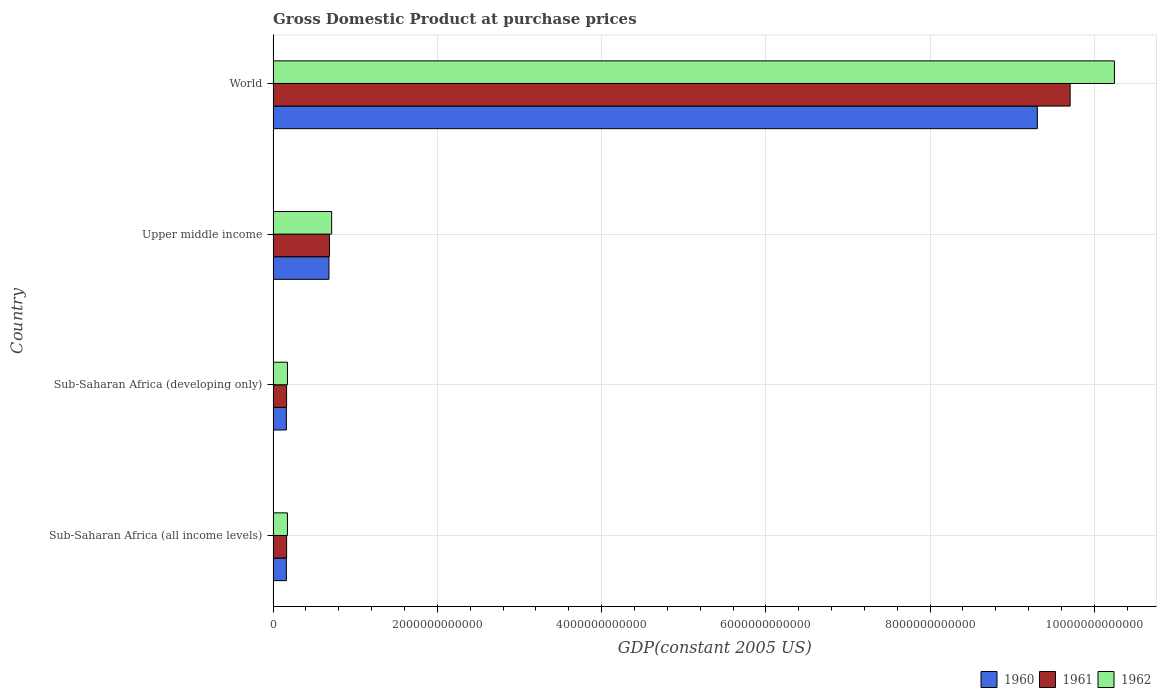How many different coloured bars are there?
Provide a succinct answer. 3. Are the number of bars per tick equal to the number of legend labels?
Provide a succinct answer. Yes. Are the number of bars on each tick of the Y-axis equal?
Provide a short and direct response. Yes. How many bars are there on the 2nd tick from the bottom?
Give a very brief answer. 3. What is the label of the 3rd group of bars from the top?
Your response must be concise. Sub-Saharan Africa (developing only). In how many cases, is the number of bars for a given country not equal to the number of legend labels?
Provide a succinct answer. 0. What is the GDP at purchase prices in 1962 in Upper middle income?
Offer a very short reply. 7.13e+11. Across all countries, what is the maximum GDP at purchase prices in 1961?
Your answer should be very brief. 9.71e+12. Across all countries, what is the minimum GDP at purchase prices in 1962?
Keep it short and to the point. 1.74e+11. In which country was the GDP at purchase prices in 1961 minimum?
Provide a short and direct response. Sub-Saharan Africa (developing only). What is the total GDP at purchase prices in 1962 in the graph?
Your answer should be compact. 1.13e+13. What is the difference between the GDP at purchase prices in 1960 in Sub-Saharan Africa (all income levels) and that in Sub-Saharan Africa (developing only)?
Offer a terse response. 6.39e+07. What is the difference between the GDP at purchase prices in 1960 in Sub-Saharan Africa (developing only) and the GDP at purchase prices in 1961 in World?
Offer a terse response. -9.54e+12. What is the average GDP at purchase prices in 1960 per country?
Offer a terse response. 2.58e+12. What is the difference between the GDP at purchase prices in 1962 and GDP at purchase prices in 1960 in Sub-Saharan Africa (developing only)?
Offer a terse response. 1.28e+1. In how many countries, is the GDP at purchase prices in 1962 greater than 3600000000000 US$?
Offer a terse response. 1. What is the ratio of the GDP at purchase prices in 1960 in Sub-Saharan Africa (all income levels) to that in Upper middle income?
Your response must be concise. 0.24. Is the GDP at purchase prices in 1961 in Sub-Saharan Africa (all income levels) less than that in Upper middle income?
Provide a succinct answer. Yes. What is the difference between the highest and the second highest GDP at purchase prices in 1961?
Provide a short and direct response. 9.02e+12. What is the difference between the highest and the lowest GDP at purchase prices in 1960?
Keep it short and to the point. 9.14e+12. In how many countries, is the GDP at purchase prices in 1960 greater than the average GDP at purchase prices in 1960 taken over all countries?
Ensure brevity in your answer.  1. Is the sum of the GDP at purchase prices in 1961 in Sub-Saharan Africa (all income levels) and Upper middle income greater than the maximum GDP at purchase prices in 1960 across all countries?
Provide a succinct answer. No. What does the 1st bar from the top in Sub-Saharan Africa (all income levels) represents?
Provide a succinct answer. 1962. Are all the bars in the graph horizontal?
Ensure brevity in your answer.  Yes. What is the difference between two consecutive major ticks on the X-axis?
Give a very brief answer. 2.00e+12. Does the graph contain any zero values?
Provide a succinct answer. No. Where does the legend appear in the graph?
Offer a very short reply. Bottom right. How are the legend labels stacked?
Give a very brief answer. Horizontal. What is the title of the graph?
Give a very brief answer. Gross Domestic Product at purchase prices. What is the label or title of the X-axis?
Give a very brief answer. GDP(constant 2005 US). What is the label or title of the Y-axis?
Ensure brevity in your answer.  Country. What is the GDP(constant 2005 US) of 1960 in Sub-Saharan Africa (all income levels)?
Provide a short and direct response. 1.61e+11. What is the GDP(constant 2005 US) in 1961 in Sub-Saharan Africa (all income levels)?
Your answer should be compact. 1.64e+11. What is the GDP(constant 2005 US) of 1962 in Sub-Saharan Africa (all income levels)?
Provide a short and direct response. 1.74e+11. What is the GDP(constant 2005 US) of 1960 in Sub-Saharan Africa (developing only)?
Provide a succinct answer. 1.61e+11. What is the GDP(constant 2005 US) in 1961 in Sub-Saharan Africa (developing only)?
Your answer should be compact. 1.64e+11. What is the GDP(constant 2005 US) of 1962 in Sub-Saharan Africa (developing only)?
Give a very brief answer. 1.74e+11. What is the GDP(constant 2005 US) of 1960 in Upper middle income?
Your response must be concise. 6.80e+11. What is the GDP(constant 2005 US) of 1961 in Upper middle income?
Keep it short and to the point. 6.86e+11. What is the GDP(constant 2005 US) of 1962 in Upper middle income?
Offer a terse response. 7.13e+11. What is the GDP(constant 2005 US) in 1960 in World?
Offer a very short reply. 9.31e+12. What is the GDP(constant 2005 US) of 1961 in World?
Give a very brief answer. 9.71e+12. What is the GDP(constant 2005 US) in 1962 in World?
Keep it short and to the point. 1.02e+13. Across all countries, what is the maximum GDP(constant 2005 US) of 1960?
Offer a terse response. 9.31e+12. Across all countries, what is the maximum GDP(constant 2005 US) of 1961?
Your response must be concise. 9.71e+12. Across all countries, what is the maximum GDP(constant 2005 US) of 1962?
Offer a very short reply. 1.02e+13. Across all countries, what is the minimum GDP(constant 2005 US) of 1960?
Your answer should be very brief. 1.61e+11. Across all countries, what is the minimum GDP(constant 2005 US) of 1961?
Your answer should be compact. 1.64e+11. Across all countries, what is the minimum GDP(constant 2005 US) of 1962?
Give a very brief answer. 1.74e+11. What is the total GDP(constant 2005 US) of 1960 in the graph?
Keep it short and to the point. 1.03e+13. What is the total GDP(constant 2005 US) in 1961 in the graph?
Keep it short and to the point. 1.07e+13. What is the total GDP(constant 2005 US) of 1962 in the graph?
Ensure brevity in your answer.  1.13e+13. What is the difference between the GDP(constant 2005 US) of 1960 in Sub-Saharan Africa (all income levels) and that in Sub-Saharan Africa (developing only)?
Keep it short and to the point. 6.39e+07. What is the difference between the GDP(constant 2005 US) in 1961 in Sub-Saharan Africa (all income levels) and that in Sub-Saharan Africa (developing only)?
Your answer should be very brief. 5.44e+07. What is the difference between the GDP(constant 2005 US) in 1962 in Sub-Saharan Africa (all income levels) and that in Sub-Saharan Africa (developing only)?
Offer a very short reply. 6.12e+07. What is the difference between the GDP(constant 2005 US) of 1960 in Sub-Saharan Africa (all income levels) and that in Upper middle income?
Keep it short and to the point. -5.19e+11. What is the difference between the GDP(constant 2005 US) in 1961 in Sub-Saharan Africa (all income levels) and that in Upper middle income?
Make the answer very short. -5.22e+11. What is the difference between the GDP(constant 2005 US) of 1962 in Sub-Saharan Africa (all income levels) and that in Upper middle income?
Your answer should be compact. -5.38e+11. What is the difference between the GDP(constant 2005 US) of 1960 in Sub-Saharan Africa (all income levels) and that in World?
Your answer should be very brief. -9.14e+12. What is the difference between the GDP(constant 2005 US) in 1961 in Sub-Saharan Africa (all income levels) and that in World?
Keep it short and to the point. -9.54e+12. What is the difference between the GDP(constant 2005 US) of 1962 in Sub-Saharan Africa (all income levels) and that in World?
Your answer should be compact. -1.01e+13. What is the difference between the GDP(constant 2005 US) in 1960 in Sub-Saharan Africa (developing only) and that in Upper middle income?
Your answer should be very brief. -5.19e+11. What is the difference between the GDP(constant 2005 US) in 1961 in Sub-Saharan Africa (developing only) and that in Upper middle income?
Give a very brief answer. -5.22e+11. What is the difference between the GDP(constant 2005 US) of 1962 in Sub-Saharan Africa (developing only) and that in Upper middle income?
Provide a short and direct response. -5.38e+11. What is the difference between the GDP(constant 2005 US) of 1960 in Sub-Saharan Africa (developing only) and that in World?
Provide a short and direct response. -9.14e+12. What is the difference between the GDP(constant 2005 US) of 1961 in Sub-Saharan Africa (developing only) and that in World?
Keep it short and to the point. -9.54e+12. What is the difference between the GDP(constant 2005 US) in 1962 in Sub-Saharan Africa (developing only) and that in World?
Your answer should be compact. -1.01e+13. What is the difference between the GDP(constant 2005 US) of 1960 in Upper middle income and that in World?
Ensure brevity in your answer.  -8.63e+12. What is the difference between the GDP(constant 2005 US) of 1961 in Upper middle income and that in World?
Ensure brevity in your answer.  -9.02e+12. What is the difference between the GDP(constant 2005 US) of 1962 in Upper middle income and that in World?
Keep it short and to the point. -9.53e+12. What is the difference between the GDP(constant 2005 US) of 1960 in Sub-Saharan Africa (all income levels) and the GDP(constant 2005 US) of 1961 in Sub-Saharan Africa (developing only)?
Ensure brevity in your answer.  -2.68e+09. What is the difference between the GDP(constant 2005 US) in 1960 in Sub-Saharan Africa (all income levels) and the GDP(constant 2005 US) in 1962 in Sub-Saharan Africa (developing only)?
Give a very brief answer. -1.28e+1. What is the difference between the GDP(constant 2005 US) in 1961 in Sub-Saharan Africa (all income levels) and the GDP(constant 2005 US) in 1962 in Sub-Saharan Africa (developing only)?
Keep it short and to the point. -1.00e+1. What is the difference between the GDP(constant 2005 US) of 1960 in Sub-Saharan Africa (all income levels) and the GDP(constant 2005 US) of 1961 in Upper middle income?
Your answer should be very brief. -5.25e+11. What is the difference between the GDP(constant 2005 US) of 1960 in Sub-Saharan Africa (all income levels) and the GDP(constant 2005 US) of 1962 in Upper middle income?
Offer a terse response. -5.51e+11. What is the difference between the GDP(constant 2005 US) in 1961 in Sub-Saharan Africa (all income levels) and the GDP(constant 2005 US) in 1962 in Upper middle income?
Offer a terse response. -5.48e+11. What is the difference between the GDP(constant 2005 US) of 1960 in Sub-Saharan Africa (all income levels) and the GDP(constant 2005 US) of 1961 in World?
Keep it short and to the point. -9.54e+12. What is the difference between the GDP(constant 2005 US) in 1960 in Sub-Saharan Africa (all income levels) and the GDP(constant 2005 US) in 1962 in World?
Make the answer very short. -1.01e+13. What is the difference between the GDP(constant 2005 US) in 1961 in Sub-Saharan Africa (all income levels) and the GDP(constant 2005 US) in 1962 in World?
Provide a succinct answer. -1.01e+13. What is the difference between the GDP(constant 2005 US) in 1960 in Sub-Saharan Africa (developing only) and the GDP(constant 2005 US) in 1961 in Upper middle income?
Keep it short and to the point. -5.25e+11. What is the difference between the GDP(constant 2005 US) in 1960 in Sub-Saharan Africa (developing only) and the GDP(constant 2005 US) in 1962 in Upper middle income?
Offer a terse response. -5.51e+11. What is the difference between the GDP(constant 2005 US) in 1961 in Sub-Saharan Africa (developing only) and the GDP(constant 2005 US) in 1962 in Upper middle income?
Offer a very short reply. -5.48e+11. What is the difference between the GDP(constant 2005 US) of 1960 in Sub-Saharan Africa (developing only) and the GDP(constant 2005 US) of 1961 in World?
Your answer should be very brief. -9.54e+12. What is the difference between the GDP(constant 2005 US) of 1960 in Sub-Saharan Africa (developing only) and the GDP(constant 2005 US) of 1962 in World?
Your answer should be very brief. -1.01e+13. What is the difference between the GDP(constant 2005 US) in 1961 in Sub-Saharan Africa (developing only) and the GDP(constant 2005 US) in 1962 in World?
Keep it short and to the point. -1.01e+13. What is the difference between the GDP(constant 2005 US) in 1960 in Upper middle income and the GDP(constant 2005 US) in 1961 in World?
Ensure brevity in your answer.  -9.03e+12. What is the difference between the GDP(constant 2005 US) in 1960 in Upper middle income and the GDP(constant 2005 US) in 1962 in World?
Give a very brief answer. -9.56e+12. What is the difference between the GDP(constant 2005 US) of 1961 in Upper middle income and the GDP(constant 2005 US) of 1962 in World?
Your response must be concise. -9.56e+12. What is the average GDP(constant 2005 US) in 1960 per country?
Offer a very short reply. 2.58e+12. What is the average GDP(constant 2005 US) of 1961 per country?
Your answer should be compact. 2.68e+12. What is the average GDP(constant 2005 US) in 1962 per country?
Offer a very short reply. 2.83e+12. What is the difference between the GDP(constant 2005 US) of 1960 and GDP(constant 2005 US) of 1961 in Sub-Saharan Africa (all income levels)?
Give a very brief answer. -2.73e+09. What is the difference between the GDP(constant 2005 US) in 1960 and GDP(constant 2005 US) in 1962 in Sub-Saharan Africa (all income levels)?
Offer a terse response. -1.28e+1. What is the difference between the GDP(constant 2005 US) in 1961 and GDP(constant 2005 US) in 1962 in Sub-Saharan Africa (all income levels)?
Offer a terse response. -1.01e+1. What is the difference between the GDP(constant 2005 US) in 1960 and GDP(constant 2005 US) in 1961 in Sub-Saharan Africa (developing only)?
Your response must be concise. -2.74e+09. What is the difference between the GDP(constant 2005 US) in 1960 and GDP(constant 2005 US) in 1962 in Sub-Saharan Africa (developing only)?
Your answer should be very brief. -1.28e+1. What is the difference between the GDP(constant 2005 US) in 1961 and GDP(constant 2005 US) in 1962 in Sub-Saharan Africa (developing only)?
Give a very brief answer. -1.01e+1. What is the difference between the GDP(constant 2005 US) in 1960 and GDP(constant 2005 US) in 1961 in Upper middle income?
Your answer should be compact. -6.01e+09. What is the difference between the GDP(constant 2005 US) in 1960 and GDP(constant 2005 US) in 1962 in Upper middle income?
Your response must be concise. -3.26e+1. What is the difference between the GDP(constant 2005 US) of 1961 and GDP(constant 2005 US) of 1962 in Upper middle income?
Keep it short and to the point. -2.66e+1. What is the difference between the GDP(constant 2005 US) of 1960 and GDP(constant 2005 US) of 1961 in World?
Keep it short and to the point. -3.99e+11. What is the difference between the GDP(constant 2005 US) of 1960 and GDP(constant 2005 US) of 1962 in World?
Provide a succinct answer. -9.39e+11. What is the difference between the GDP(constant 2005 US) in 1961 and GDP(constant 2005 US) in 1962 in World?
Keep it short and to the point. -5.39e+11. What is the ratio of the GDP(constant 2005 US) of 1962 in Sub-Saharan Africa (all income levels) to that in Sub-Saharan Africa (developing only)?
Provide a succinct answer. 1. What is the ratio of the GDP(constant 2005 US) in 1960 in Sub-Saharan Africa (all income levels) to that in Upper middle income?
Your answer should be very brief. 0.24. What is the ratio of the GDP(constant 2005 US) of 1961 in Sub-Saharan Africa (all income levels) to that in Upper middle income?
Provide a short and direct response. 0.24. What is the ratio of the GDP(constant 2005 US) in 1962 in Sub-Saharan Africa (all income levels) to that in Upper middle income?
Keep it short and to the point. 0.24. What is the ratio of the GDP(constant 2005 US) in 1960 in Sub-Saharan Africa (all income levels) to that in World?
Your answer should be very brief. 0.02. What is the ratio of the GDP(constant 2005 US) of 1961 in Sub-Saharan Africa (all income levels) to that in World?
Give a very brief answer. 0.02. What is the ratio of the GDP(constant 2005 US) of 1962 in Sub-Saharan Africa (all income levels) to that in World?
Your answer should be compact. 0.02. What is the ratio of the GDP(constant 2005 US) in 1960 in Sub-Saharan Africa (developing only) to that in Upper middle income?
Your response must be concise. 0.24. What is the ratio of the GDP(constant 2005 US) in 1961 in Sub-Saharan Africa (developing only) to that in Upper middle income?
Keep it short and to the point. 0.24. What is the ratio of the GDP(constant 2005 US) of 1962 in Sub-Saharan Africa (developing only) to that in Upper middle income?
Keep it short and to the point. 0.24. What is the ratio of the GDP(constant 2005 US) in 1960 in Sub-Saharan Africa (developing only) to that in World?
Keep it short and to the point. 0.02. What is the ratio of the GDP(constant 2005 US) in 1961 in Sub-Saharan Africa (developing only) to that in World?
Your answer should be very brief. 0.02. What is the ratio of the GDP(constant 2005 US) of 1962 in Sub-Saharan Africa (developing only) to that in World?
Provide a succinct answer. 0.02. What is the ratio of the GDP(constant 2005 US) in 1960 in Upper middle income to that in World?
Provide a short and direct response. 0.07. What is the ratio of the GDP(constant 2005 US) of 1961 in Upper middle income to that in World?
Provide a succinct answer. 0.07. What is the ratio of the GDP(constant 2005 US) of 1962 in Upper middle income to that in World?
Provide a short and direct response. 0.07. What is the difference between the highest and the second highest GDP(constant 2005 US) in 1960?
Your answer should be very brief. 8.63e+12. What is the difference between the highest and the second highest GDP(constant 2005 US) in 1961?
Make the answer very short. 9.02e+12. What is the difference between the highest and the second highest GDP(constant 2005 US) in 1962?
Provide a short and direct response. 9.53e+12. What is the difference between the highest and the lowest GDP(constant 2005 US) in 1960?
Your answer should be compact. 9.14e+12. What is the difference between the highest and the lowest GDP(constant 2005 US) in 1961?
Offer a very short reply. 9.54e+12. What is the difference between the highest and the lowest GDP(constant 2005 US) in 1962?
Make the answer very short. 1.01e+13. 